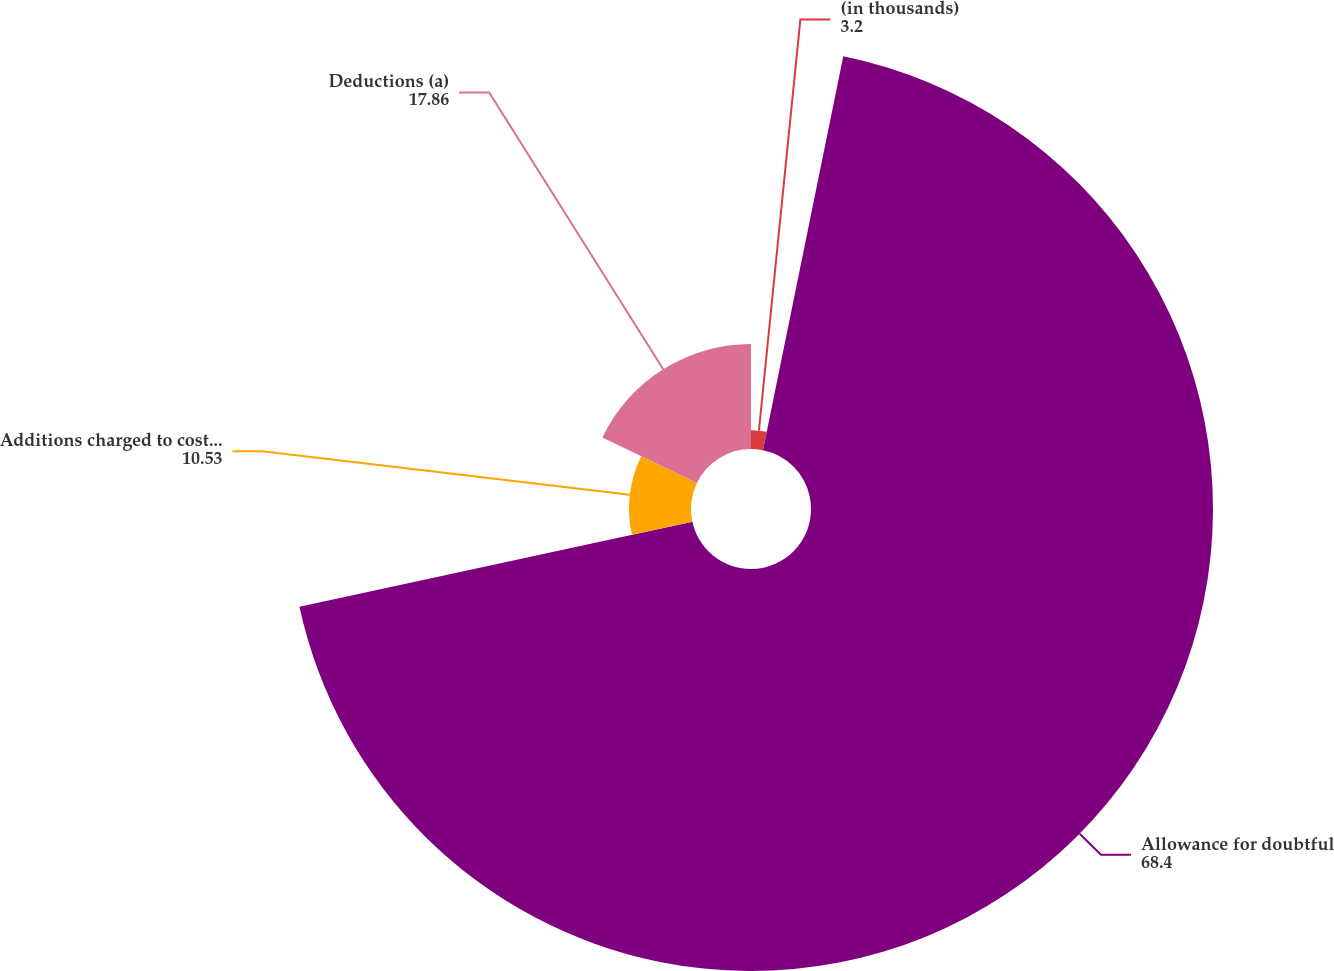Convert chart. <chart><loc_0><loc_0><loc_500><loc_500><pie_chart><fcel>(in thousands)<fcel>Allowance for doubtful<fcel>Additions charged to costs and<fcel>Deductions (a)<nl><fcel>3.2%<fcel>68.4%<fcel>10.53%<fcel>17.86%<nl></chart> 